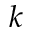Convert formula to latex. <formula><loc_0><loc_0><loc_500><loc_500>k</formula> 